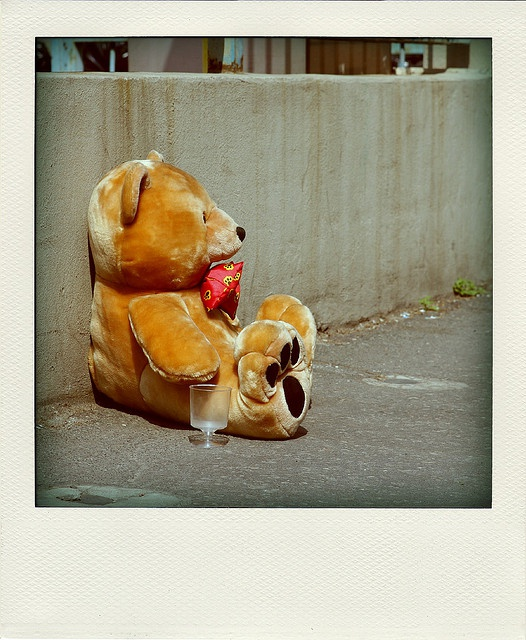Describe the objects in this image and their specific colors. I can see teddy bear in lightgray, olive, maroon, orange, and tan tones, wine glass in lightgray, tan, darkgray, maroon, and gray tones, and tie in lightgray, maroon, salmon, brown, and red tones in this image. 